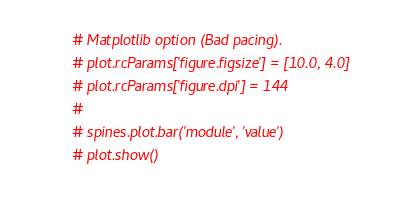<code> <loc_0><loc_0><loc_500><loc_500><_Python_>
# Matplotlib option (Bad pacing).
# plot.rcParams['figure.figsize'] = [10.0, 4.0]
# plot.rcParams['figure.dpi'] = 144
#
# spines.plot.bar('module', 'value')
# plot.show()
</code> 